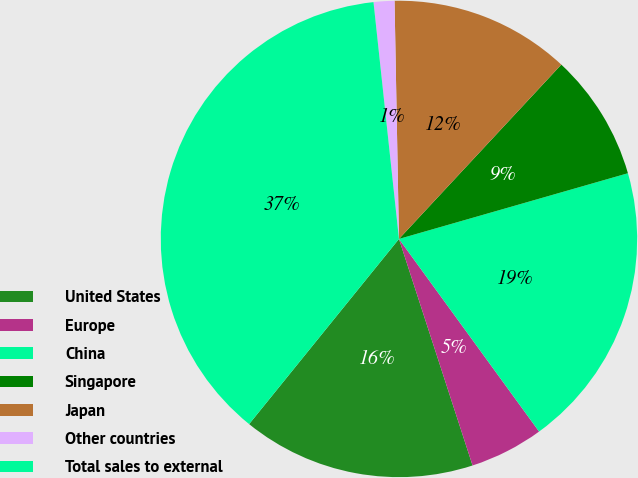<chart> <loc_0><loc_0><loc_500><loc_500><pie_chart><fcel>United States<fcel>Europe<fcel>China<fcel>Singapore<fcel>Japan<fcel>Other countries<fcel>Total sales to external<nl><fcel>15.83%<fcel>5.01%<fcel>19.44%<fcel>8.62%<fcel>12.23%<fcel>1.41%<fcel>37.47%<nl></chart> 